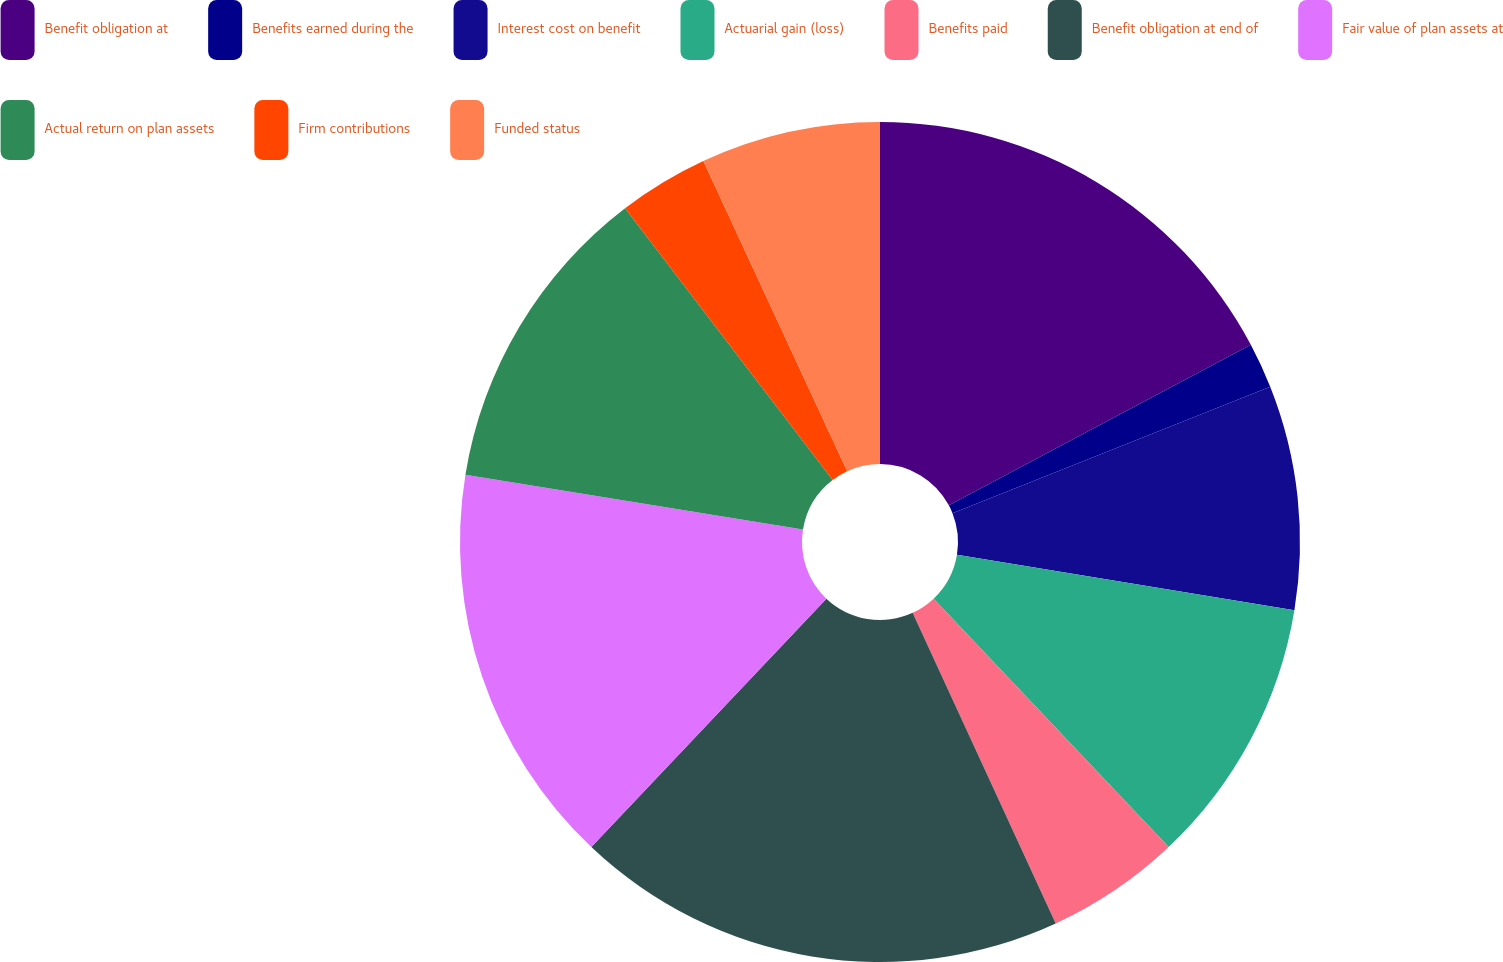Convert chart. <chart><loc_0><loc_0><loc_500><loc_500><pie_chart><fcel>Benefit obligation at<fcel>Benefits earned during the<fcel>Interest cost on benefit<fcel>Actuarial gain (loss)<fcel>Benefits paid<fcel>Benefit obligation at end of<fcel>Fair value of plan assets at<fcel>Actual return on plan assets<fcel>Firm contributions<fcel>Funded status<nl><fcel>17.22%<fcel>1.75%<fcel>8.63%<fcel>10.34%<fcel>5.19%<fcel>18.93%<fcel>15.5%<fcel>12.06%<fcel>3.47%<fcel>6.91%<nl></chart> 